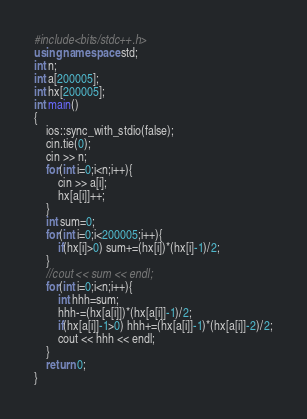Convert code to text. <code><loc_0><loc_0><loc_500><loc_500><_C++_>#include<bits/stdc++.h>
using namespace std;
int n;
int a[200005];
int hx[200005];
int main()
{
	ios::sync_with_stdio(false);
	cin.tie(0);
	cin >> n;
	for(int i=0;i<n;i++){
		cin >> a[i];
		hx[a[i]]++;
	}
	int sum=0;
	for(int i=0;i<200005;i++){
		if(hx[i]>0) sum+=(hx[i])*(hx[i]-1)/2;
	}
	//cout << sum << endl;
	for(int i=0;i<n;i++){
		int hhh=sum;
		hhh-=(hx[a[i]])*(hx[a[i]]-1)/2;
		if(hx[a[i]]-1>0) hhh+=(hx[a[i]]-1)*(hx[a[i]]-2)/2;
		cout << hhh << endl;
	}
	return 0;
}
</code> 